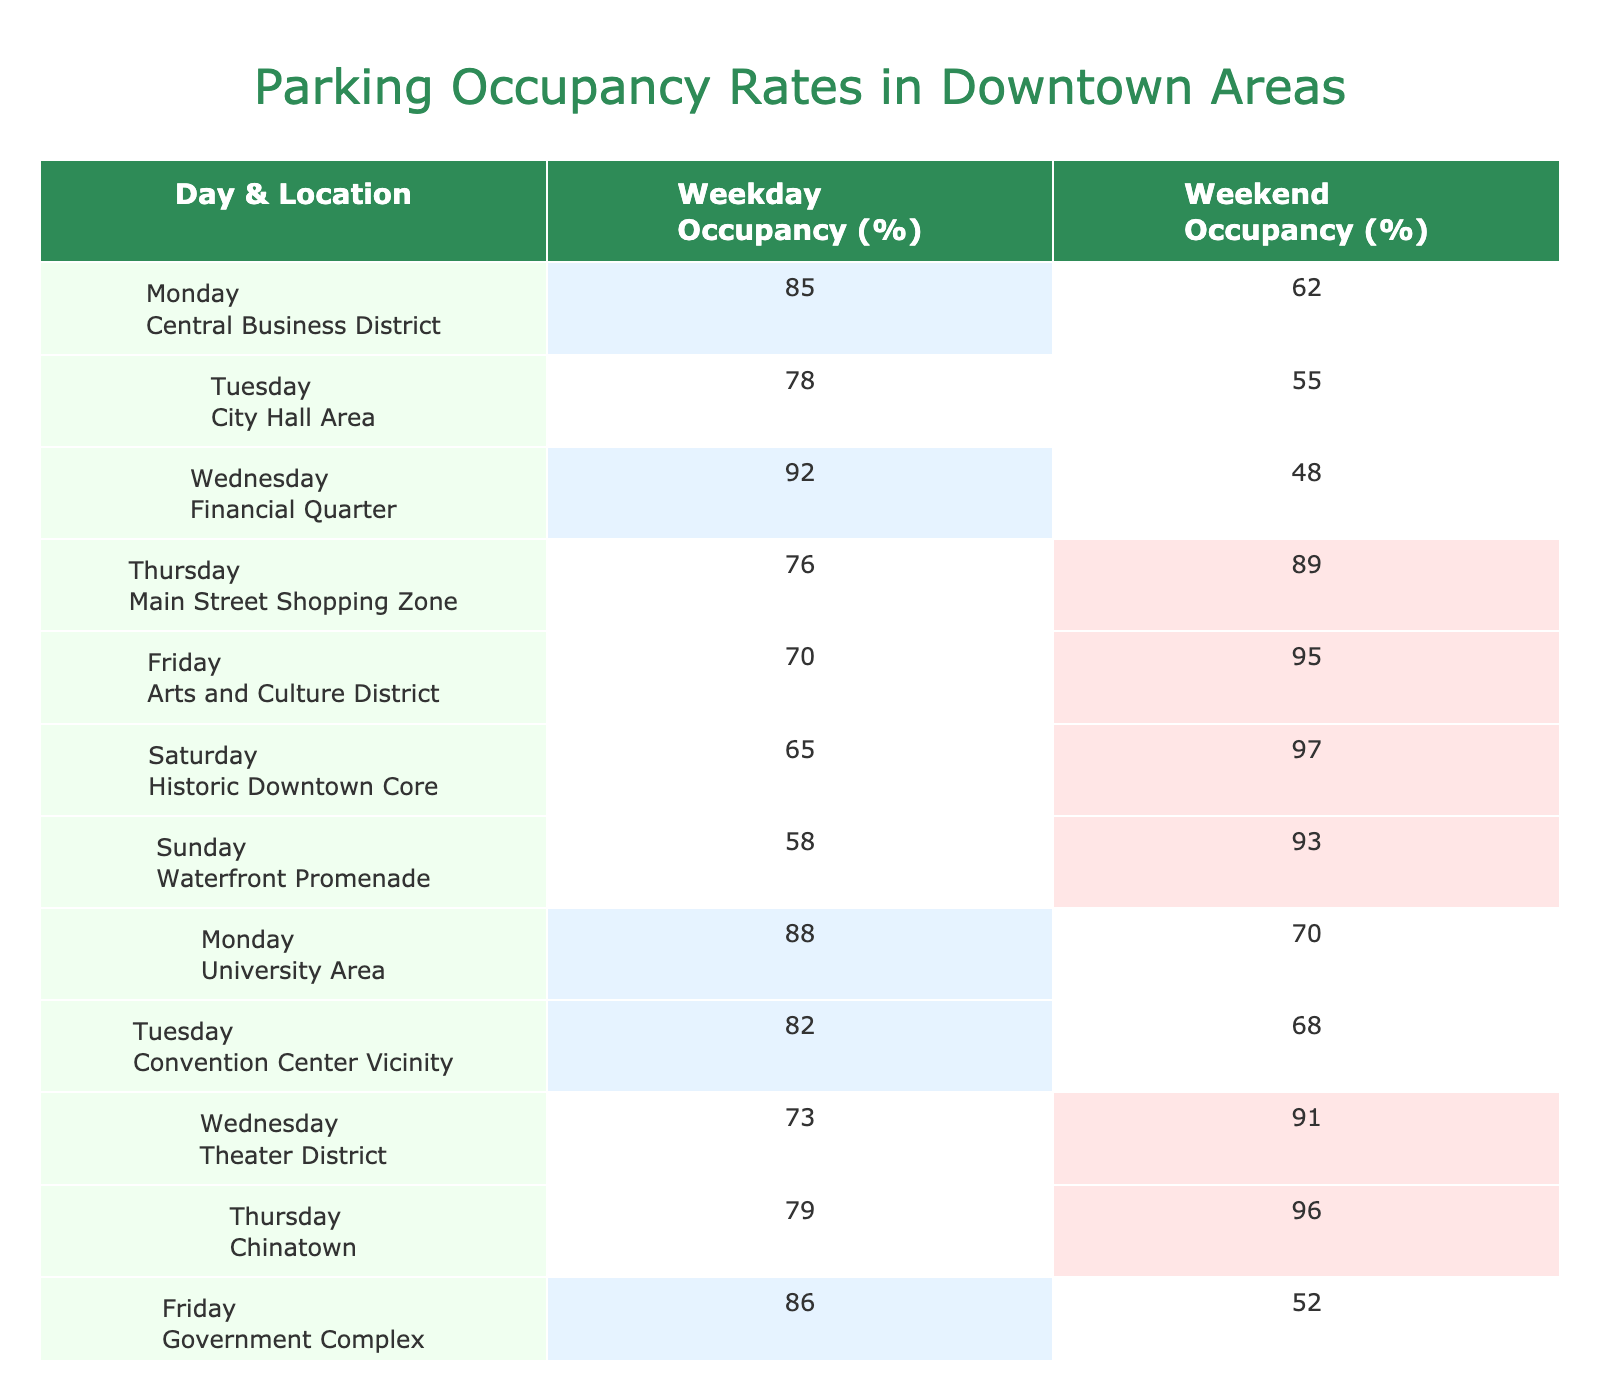What is the weekday occupancy rate for the Financial Quarter? The table shows that the Financial Quarter has a weekday occupancy rate of 92%.
Answer: 92% Which location has the highest weekend occupancy rate? From the table, the Historic Downtown Core has the highest weekend occupancy rate at 97%.
Answer: 97% What is the average weekday occupancy rate across all locations? To find the average, sum the weekday occupancy rates: 85 + 78 + 92 + 76 + 70 + 65 + 58 + 88 + 82 + 73 + 79 + 86 + 80 + 75 = 1,186. There are 14 data points, so the average is 1,186 / 14 = 84.71 (approximately 85).
Answer: 85% On which day does the Government Complex see the lowest weekend occupancy? The table indicates that the Government Complex has a weekend occupancy rate of 52%, which is the lowest for that location.
Answer: Yes Is the weekday occupancy for the University Area higher than that for the Arts and Culture District? The table shows that the University Area has a weekday occupancy of 88%, while the Arts and Culture District has a rate of 70%, confirming that the University Area is higher.
Answer: Yes What is the difference in occupancy rates between weekdays and weekends for the Chinatown area? The weekday occupancy for Chinatown is 79%, while the weekend occupancy is 96%. The difference is 96 - 79 = 17%.
Answer: 17% Which locations have a higher occupancy rate on weekends than weekdays? The data reveals that Weekend occupancy is higher than Weekday occupancy for the following locations: Main Street Shopping Zone, Arts and Culture District, Historic Downtown Core, Chinatown, and Tech Hub.
Answer: 5 locations What is the total parking occupancy percentage for all weekends combined? To calculate the total weekend occupancy, sum all weekend occupancy percentages: 62 + 55 + 48 + 89 + 95 + 97 + 93 + 70 + 68 + 91 + 96 + 52 + 61 + 64 = 1,367.
Answer: 1,367% How many locations have weekday occupancy rates below 80%? The locations with weekday occupancy below 80% are: City Hall Area (78%), Main Street Shopping Zone (76%), Arts and Culture District (70%), and the Theater District (73%). That makes a total of 4 locations.
Answer: 4 locations Is it true that the weekday occupancy in the Central Business District is more than in the Waterfront Promenade? Yes, the weekday occupancy rate for the Central Business District is 85%, while the Waterfront Promenade has a weekday occupancy of 58%.
Answer: Yes 